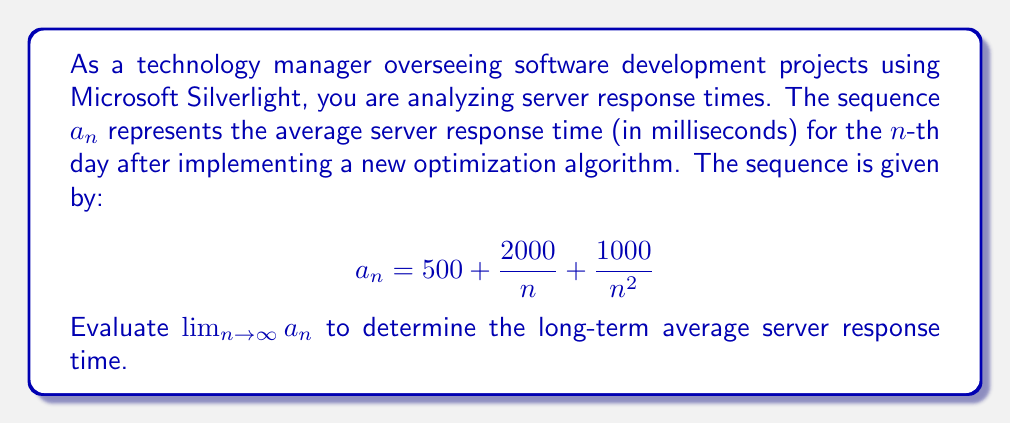Can you solve this math problem? To evaluate this limit, we'll analyze each term of the sequence as $n$ approaches infinity:

1. The constant term: $500$
   This term remains unchanged as $n$ increases.

2. The term $\frac{2000}{n}$:
   As $n$ approaches infinity, this term approaches 0:
   $$\lim_{n \to \infty} \frac{2000}{n} = 0$$

3. The term $\frac{1000}{n^2}$:
   This term also approaches 0 as $n$ approaches infinity:
   $$\lim_{n \to \infty} \frac{1000}{n^2} = 0$$

Now, we can apply the limit laws to evaluate the entire expression:

$$\begin{align}
\lim_{n \to \infty} a_n &= \lim_{n \to \infty} \left(500 + \frac{2000}{n} + \frac{1000}{n^2}\right) \\
&= \lim_{n \to \infty} 500 + \lim_{n \to \infty} \frac{2000}{n} + \lim_{n \to \infty} \frac{1000}{n^2} \\
&= 500 + 0 + 0 \\
&= 500
\end{align}$$

Therefore, the long-term average server response time converges to 500 milliseconds.
Answer: $\lim_{n \to \infty} a_n = 500$ milliseconds 